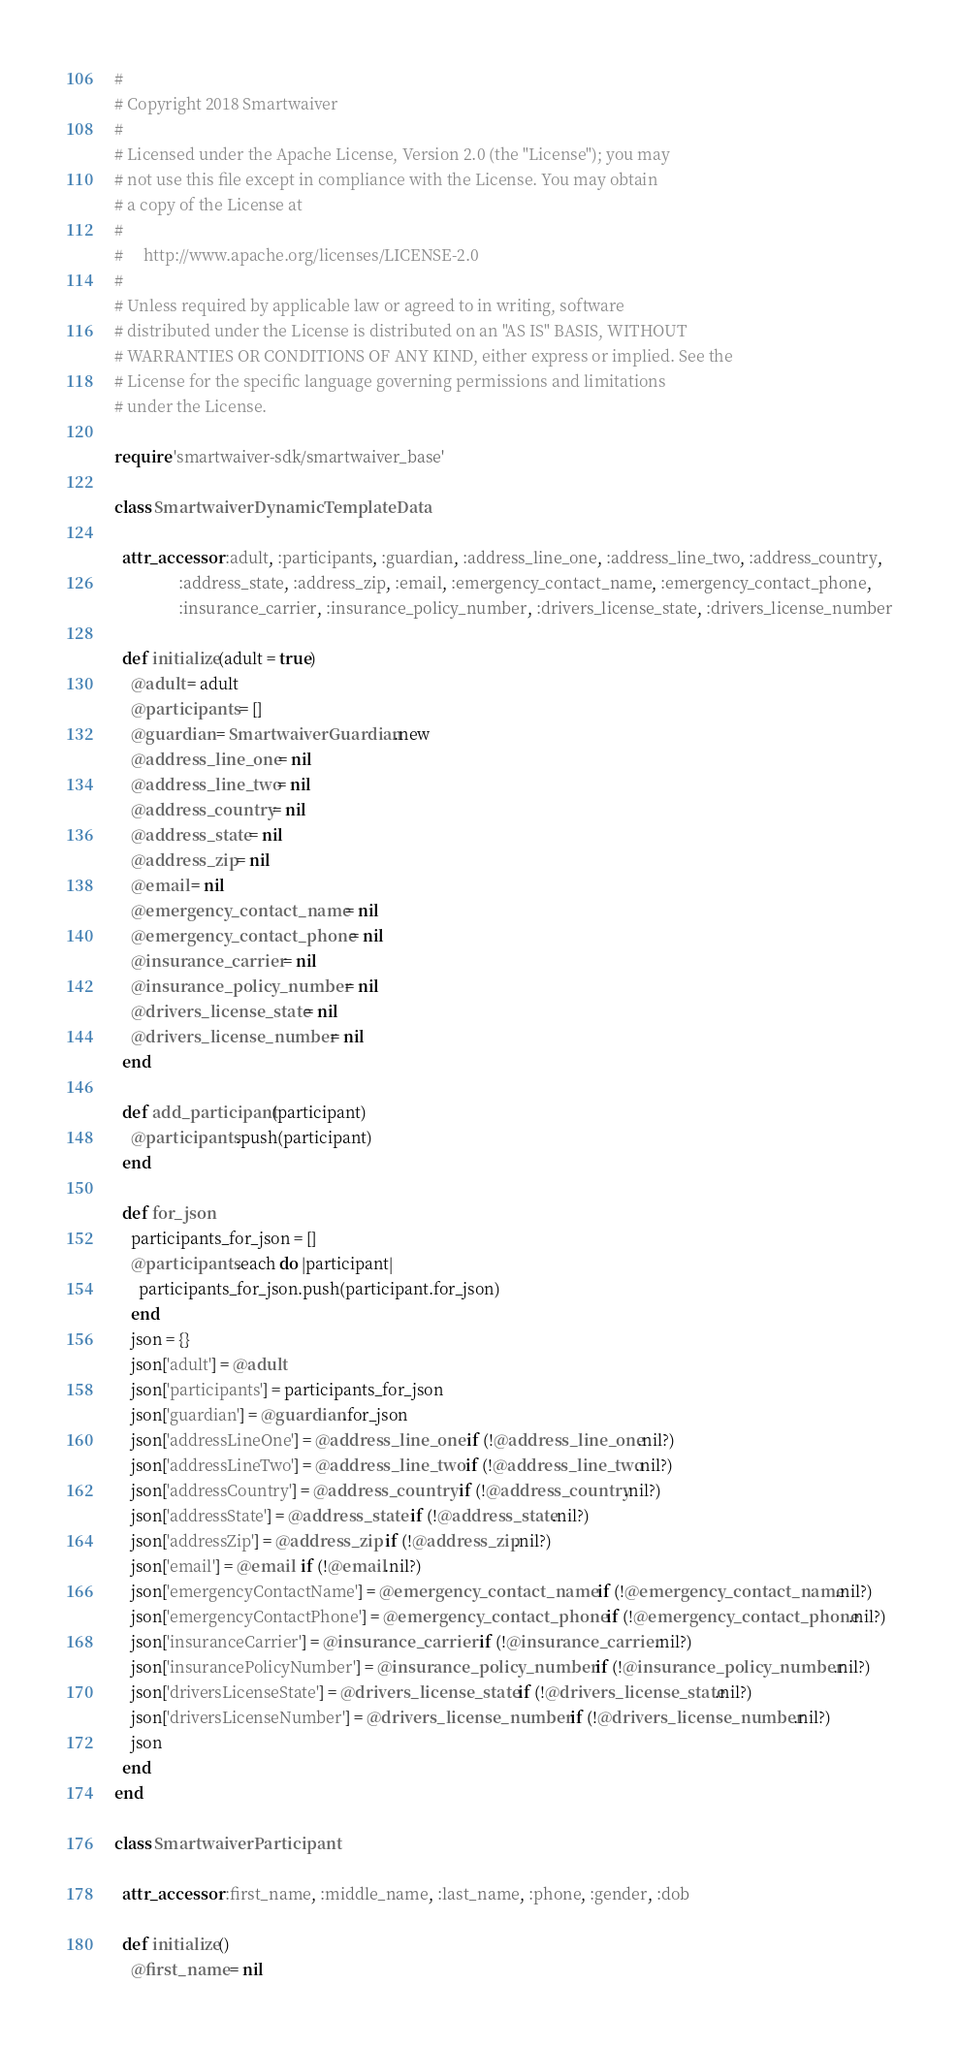<code> <loc_0><loc_0><loc_500><loc_500><_Ruby_>#
# Copyright 2018 Smartwaiver
#
# Licensed under the Apache License, Version 2.0 (the "License"); you may
# not use this file except in compliance with the License. You may obtain
# a copy of the License at
#
#     http://www.apache.org/licenses/LICENSE-2.0
#
# Unless required by applicable law or agreed to in writing, software
# distributed under the License is distributed on an "AS IS" BASIS, WITHOUT
# WARRANTIES OR CONDITIONS OF ANY KIND, either express or implied. See the
# License for the specific language governing permissions and limitations
# under the License.

require 'smartwaiver-sdk/smartwaiver_base'

class SmartwaiverDynamicTemplateData

  attr_accessor :adult, :participants, :guardian, :address_line_one, :address_line_two, :address_country,
                :address_state, :address_zip, :email, :emergency_contact_name, :emergency_contact_phone,
                :insurance_carrier, :insurance_policy_number, :drivers_license_state, :drivers_license_number

  def initialize(adult = true)
    @adult = adult
    @participants = []
    @guardian = SmartwaiverGuardian.new
    @address_line_one = nil
    @address_line_two = nil
    @address_country = nil
    @address_state = nil
    @address_zip = nil
    @email = nil
    @emergency_contact_name = nil
    @emergency_contact_phone = nil
    @insurance_carrier = nil
    @insurance_policy_number = nil
    @drivers_license_state = nil
    @drivers_license_number = nil
  end

  def add_participant(participant)
    @participants.push(participant)
  end

  def for_json
    participants_for_json = []
    @participants.each do |participant|
      participants_for_json.push(participant.for_json)
    end
    json = {}
    json['adult'] = @adult
    json['participants'] = participants_for_json
    json['guardian'] = @guardian.for_json
    json['addressLineOne'] = @address_line_one  if (!@address_line_one.nil?)
    json['addressLineTwo'] = @address_line_two  if (!@address_line_two.nil?)
    json['addressCountry'] = @address_country  if (!@address_country.nil?)
    json['addressState'] = @address_state  if (!@address_state.nil?)
    json['addressZip'] = @address_zip  if (!@address_zip.nil?)
    json['email'] = @email  if (!@email.nil?)
    json['emergencyContactName'] = @emergency_contact_name  if (!@emergency_contact_name.nil?)
    json['emergencyContactPhone'] = @emergency_contact_phone  if (!@emergency_contact_phone.nil?)
    json['insuranceCarrier'] = @insurance_carrier  if (!@insurance_carrier.nil?)
    json['insurancePolicyNumber'] = @insurance_policy_number  if (!@insurance_policy_number.nil?)
    json['driversLicenseState'] = @drivers_license_state  if (!@drivers_license_state.nil?)
    json['driversLicenseNumber'] = @drivers_license_number  if (!@drivers_license_number.nil?)
    json
  end
end

class SmartwaiverParticipant

  attr_accessor :first_name, :middle_name, :last_name, :phone, :gender, :dob

  def initialize()
    @first_name = nil</code> 